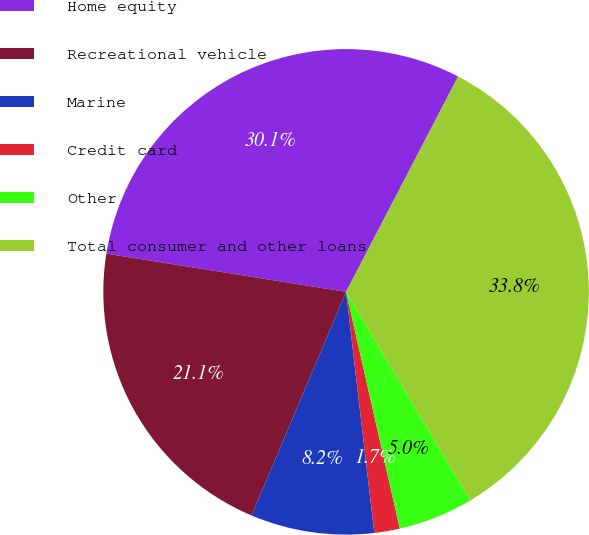<chart> <loc_0><loc_0><loc_500><loc_500><pie_chart><fcel>Home equity<fcel>Recreational vehicle<fcel>Marine<fcel>Credit card<fcel>Other<fcel>Total consumer and other loans<nl><fcel>30.12%<fcel>21.15%<fcel>8.22%<fcel>1.7%<fcel>5.0%<fcel>33.81%<nl></chart> 